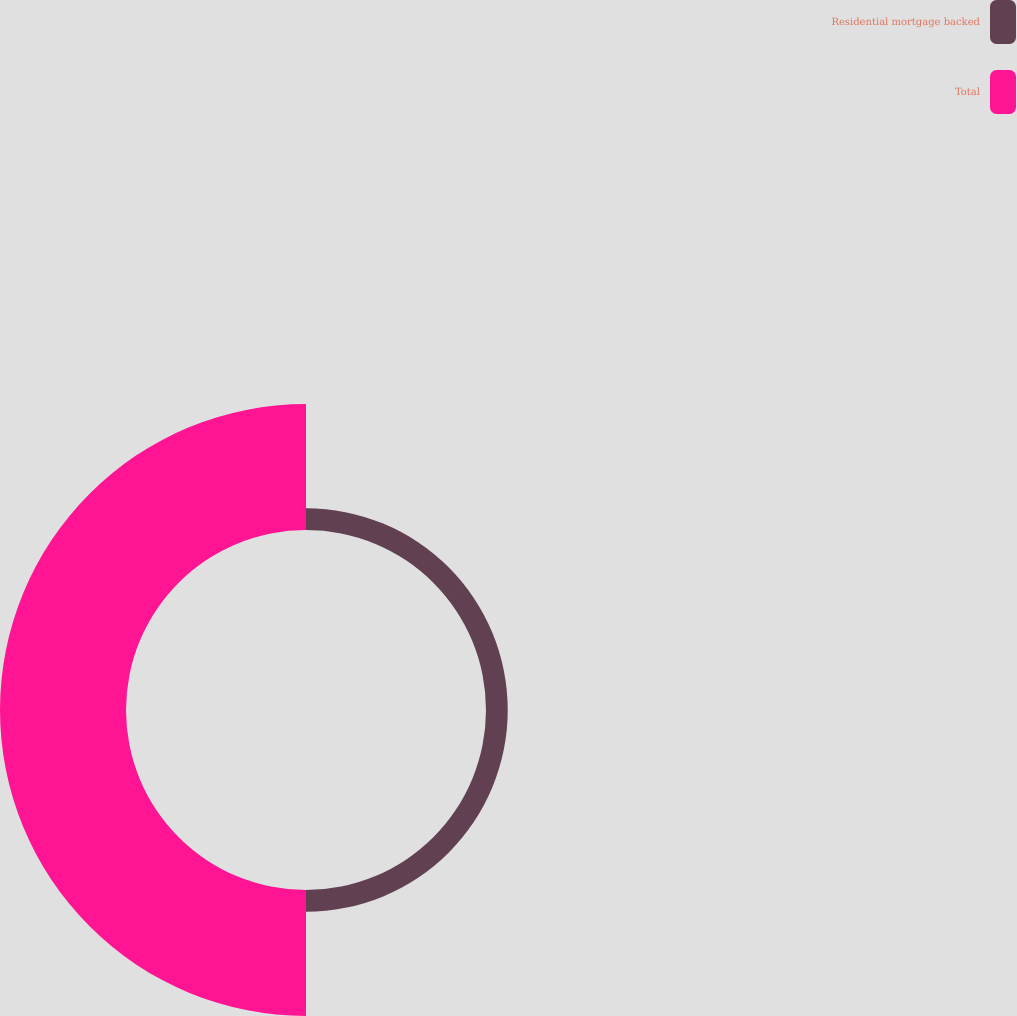Convert chart. <chart><loc_0><loc_0><loc_500><loc_500><pie_chart><fcel>Residential mortgage backed<fcel>Total<nl><fcel>14.71%<fcel>85.29%<nl></chart> 